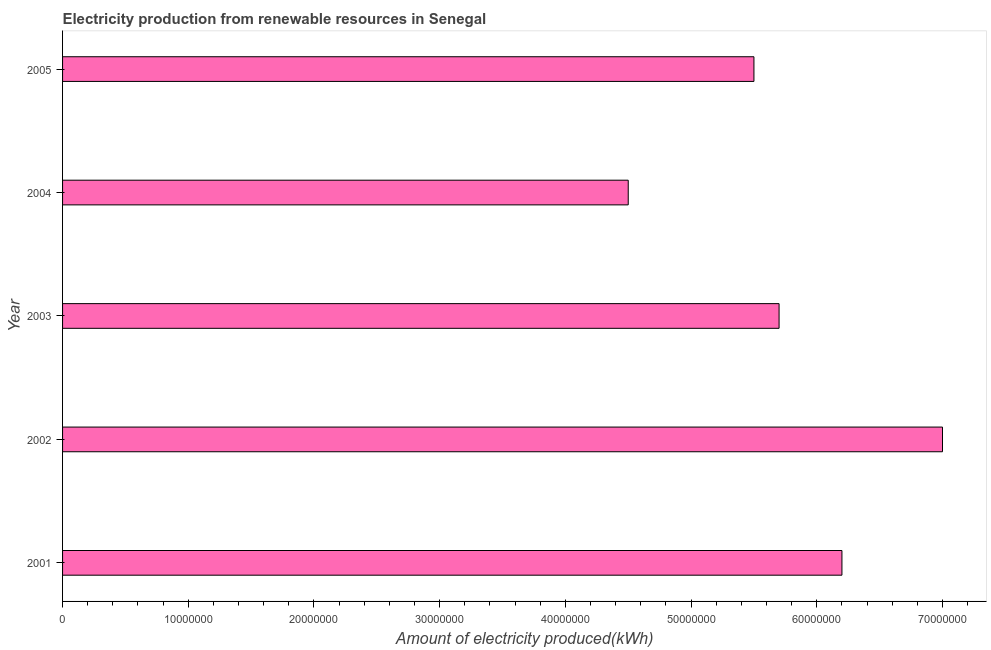Does the graph contain grids?
Give a very brief answer. No. What is the title of the graph?
Offer a terse response. Electricity production from renewable resources in Senegal. What is the label or title of the X-axis?
Give a very brief answer. Amount of electricity produced(kWh). What is the amount of electricity produced in 2003?
Make the answer very short. 5.70e+07. Across all years, what is the maximum amount of electricity produced?
Keep it short and to the point. 7.00e+07. Across all years, what is the minimum amount of electricity produced?
Offer a terse response. 4.50e+07. In which year was the amount of electricity produced maximum?
Provide a short and direct response. 2002. What is the sum of the amount of electricity produced?
Your answer should be very brief. 2.89e+08. What is the difference between the amount of electricity produced in 2001 and 2003?
Give a very brief answer. 5.00e+06. What is the average amount of electricity produced per year?
Your answer should be very brief. 5.78e+07. What is the median amount of electricity produced?
Your answer should be very brief. 5.70e+07. What is the ratio of the amount of electricity produced in 2003 to that in 2004?
Offer a terse response. 1.27. What is the difference between the highest and the second highest amount of electricity produced?
Provide a short and direct response. 8.00e+06. Is the sum of the amount of electricity produced in 2002 and 2005 greater than the maximum amount of electricity produced across all years?
Your answer should be very brief. Yes. What is the difference between the highest and the lowest amount of electricity produced?
Your response must be concise. 2.50e+07. How many bars are there?
Offer a very short reply. 5. What is the Amount of electricity produced(kWh) of 2001?
Ensure brevity in your answer.  6.20e+07. What is the Amount of electricity produced(kWh) of 2002?
Offer a very short reply. 7.00e+07. What is the Amount of electricity produced(kWh) in 2003?
Make the answer very short. 5.70e+07. What is the Amount of electricity produced(kWh) of 2004?
Your answer should be compact. 4.50e+07. What is the Amount of electricity produced(kWh) of 2005?
Make the answer very short. 5.50e+07. What is the difference between the Amount of electricity produced(kWh) in 2001 and 2002?
Your answer should be very brief. -8.00e+06. What is the difference between the Amount of electricity produced(kWh) in 2001 and 2004?
Your response must be concise. 1.70e+07. What is the difference between the Amount of electricity produced(kWh) in 2002 and 2003?
Ensure brevity in your answer.  1.30e+07. What is the difference between the Amount of electricity produced(kWh) in 2002 and 2004?
Give a very brief answer. 2.50e+07. What is the difference between the Amount of electricity produced(kWh) in 2002 and 2005?
Your response must be concise. 1.50e+07. What is the difference between the Amount of electricity produced(kWh) in 2004 and 2005?
Keep it short and to the point. -1.00e+07. What is the ratio of the Amount of electricity produced(kWh) in 2001 to that in 2002?
Provide a short and direct response. 0.89. What is the ratio of the Amount of electricity produced(kWh) in 2001 to that in 2003?
Provide a short and direct response. 1.09. What is the ratio of the Amount of electricity produced(kWh) in 2001 to that in 2004?
Make the answer very short. 1.38. What is the ratio of the Amount of electricity produced(kWh) in 2001 to that in 2005?
Make the answer very short. 1.13. What is the ratio of the Amount of electricity produced(kWh) in 2002 to that in 2003?
Offer a very short reply. 1.23. What is the ratio of the Amount of electricity produced(kWh) in 2002 to that in 2004?
Offer a terse response. 1.56. What is the ratio of the Amount of electricity produced(kWh) in 2002 to that in 2005?
Keep it short and to the point. 1.27. What is the ratio of the Amount of electricity produced(kWh) in 2003 to that in 2004?
Make the answer very short. 1.27. What is the ratio of the Amount of electricity produced(kWh) in 2003 to that in 2005?
Provide a succinct answer. 1.04. What is the ratio of the Amount of electricity produced(kWh) in 2004 to that in 2005?
Provide a short and direct response. 0.82. 